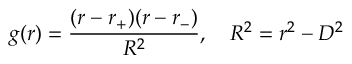Convert formula to latex. <formula><loc_0><loc_0><loc_500><loc_500>g ( r ) = { \frac { ( r - r _ { + } ) ( r - r _ { - } ) } { R ^ { 2 } } } , \quad R ^ { 2 } = r ^ { 2 } - D ^ { 2 }</formula> 